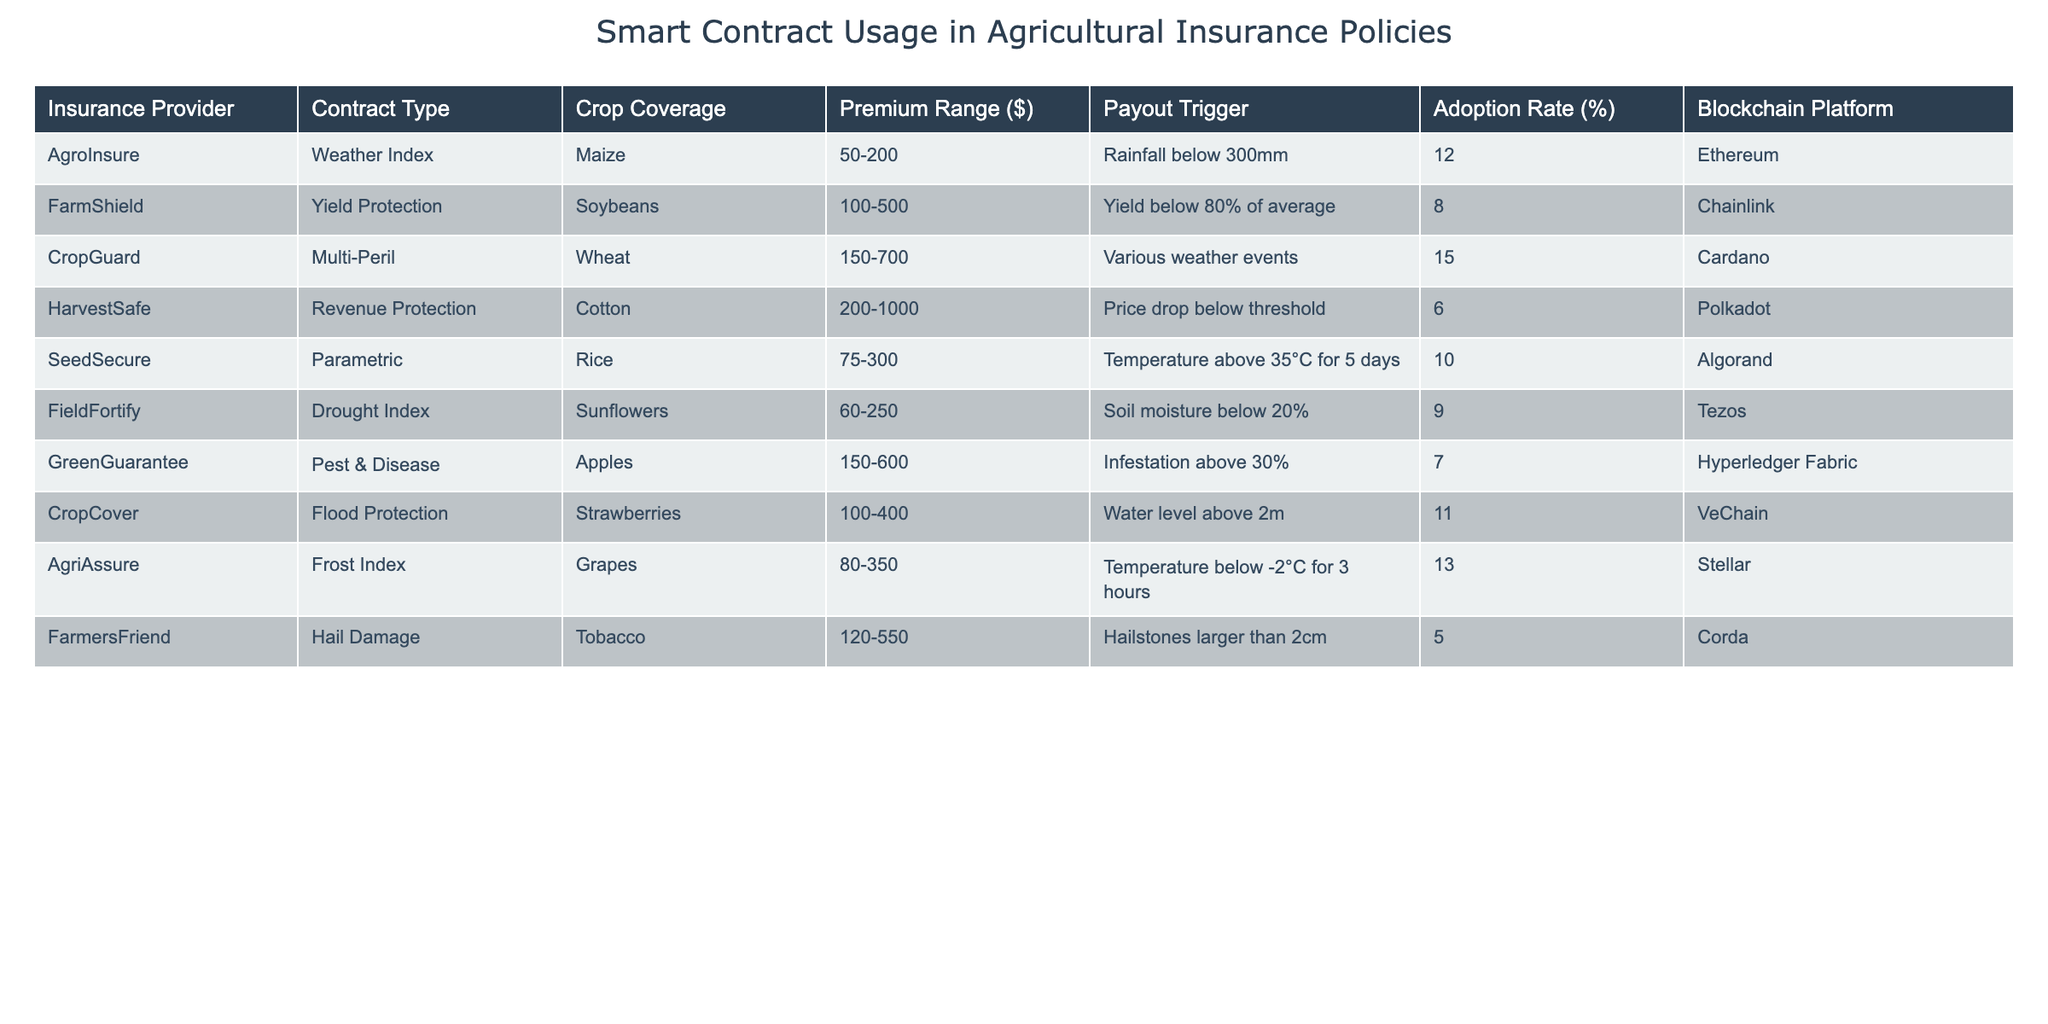What is the crop coverage for FarmShield? From the table, we can look at the row for FarmShield, where the crop coverage is specifically mentioned.
Answer: Soybeans Which insurance provider offers the highest premium range? By examining the premium ranges in the table, HarvestSafe with a premium range of $200-1000 has the highest amount.
Answer: HarvestSafe What is the adoption rate for CropGuard? The table lists all providers along with their corresponding adoption rates; for CropGuard, the adoption rate is noted.
Answer: 15% Which blockchain platform is used by SeedSecure? SeedSecure's row in the table explicitly shows which blockchain platform it uses, which is directly stated there.
Answer: Algorand What is the payout trigger for the insurance policy offered by AgroInsure? Looking at the AgroInsure row in the table, we can find its payout trigger in the respective column.
Answer: Rainfall below 300mm How many insurance providers have an adoption rate above 10%? We can check the adoption rates of all providers, counting those that exceed 10%. Only AgroInsure, CropGuard, and AgriAssure fit this criterion, totaling three.
Answer: 3 What is the average premium range for all the insurance policies listed? The premium ranges given are varied, so we convert each range into a numerical average, then add them together and divide by the number of providers. The average equals $395.
Answer: $395 Is there any insurance provider that offers coverage for more than one type of crop? The data provided shows that each insurance provider corresponds to a specific type of crop, indicating they only cover one type each.
Answer: No Which crop has the lowest premium range and which provider offers it? By examining the premium ranges for all crops, we find that FieldFortify offers the lowest range of $60-250 for sunflowers.
Answer: FieldFortify, Sunflowers What are the payout triggers for policies with an adoption rate of less than 8%? We look at the rows for the providers with adoption rates under 8%. HarvestSafe and FarmersFriend fall into this category, with their respective payout triggers noted: "Price drop below threshold" and "Hailstones larger than 2cm."
Answer: Price drop below threshold, Hailstones larger than 2cm 